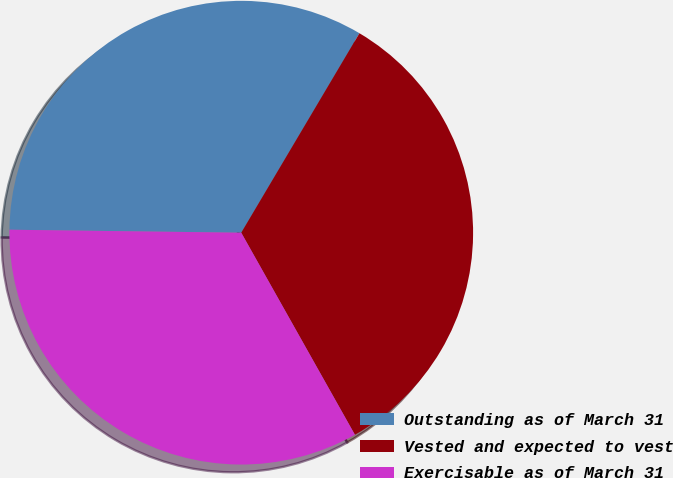<chart> <loc_0><loc_0><loc_500><loc_500><pie_chart><fcel>Outstanding as of March 31<fcel>Vested and expected to vest<fcel>Exercisable as of March 31<nl><fcel>33.31%<fcel>33.33%<fcel>33.36%<nl></chart> 